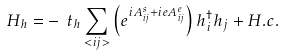Convert formula to latex. <formula><loc_0><loc_0><loc_500><loc_500>H _ { h } = - \ t _ { h } \sum _ { < i j > } \left ( e ^ { i A _ { i j } ^ { s } + i e A _ { i j } ^ { e } } \right ) h _ { i } ^ { \dagger } h _ { j } + H . c .</formula> 